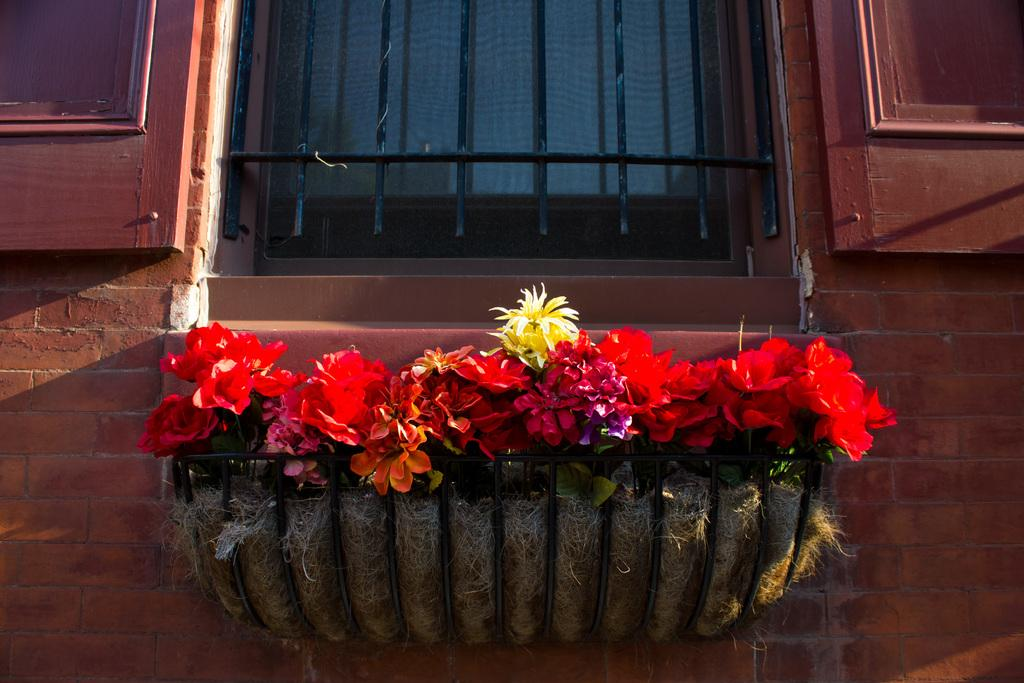What is the main subject of the image? The main subject of the image is a building wall. Can you identify any specific features on the wall? Yes, there is a window and a flower pot attached to the wall in the image. What type of space exploration is depicted in the image? There is no space exploration depicted in the image; it is a zoomed in picture of a building wall. Can you tell me how many stamps are on the wall in the image? There are no stamps present in the image; it features a building wall with a window and a flower pot. 